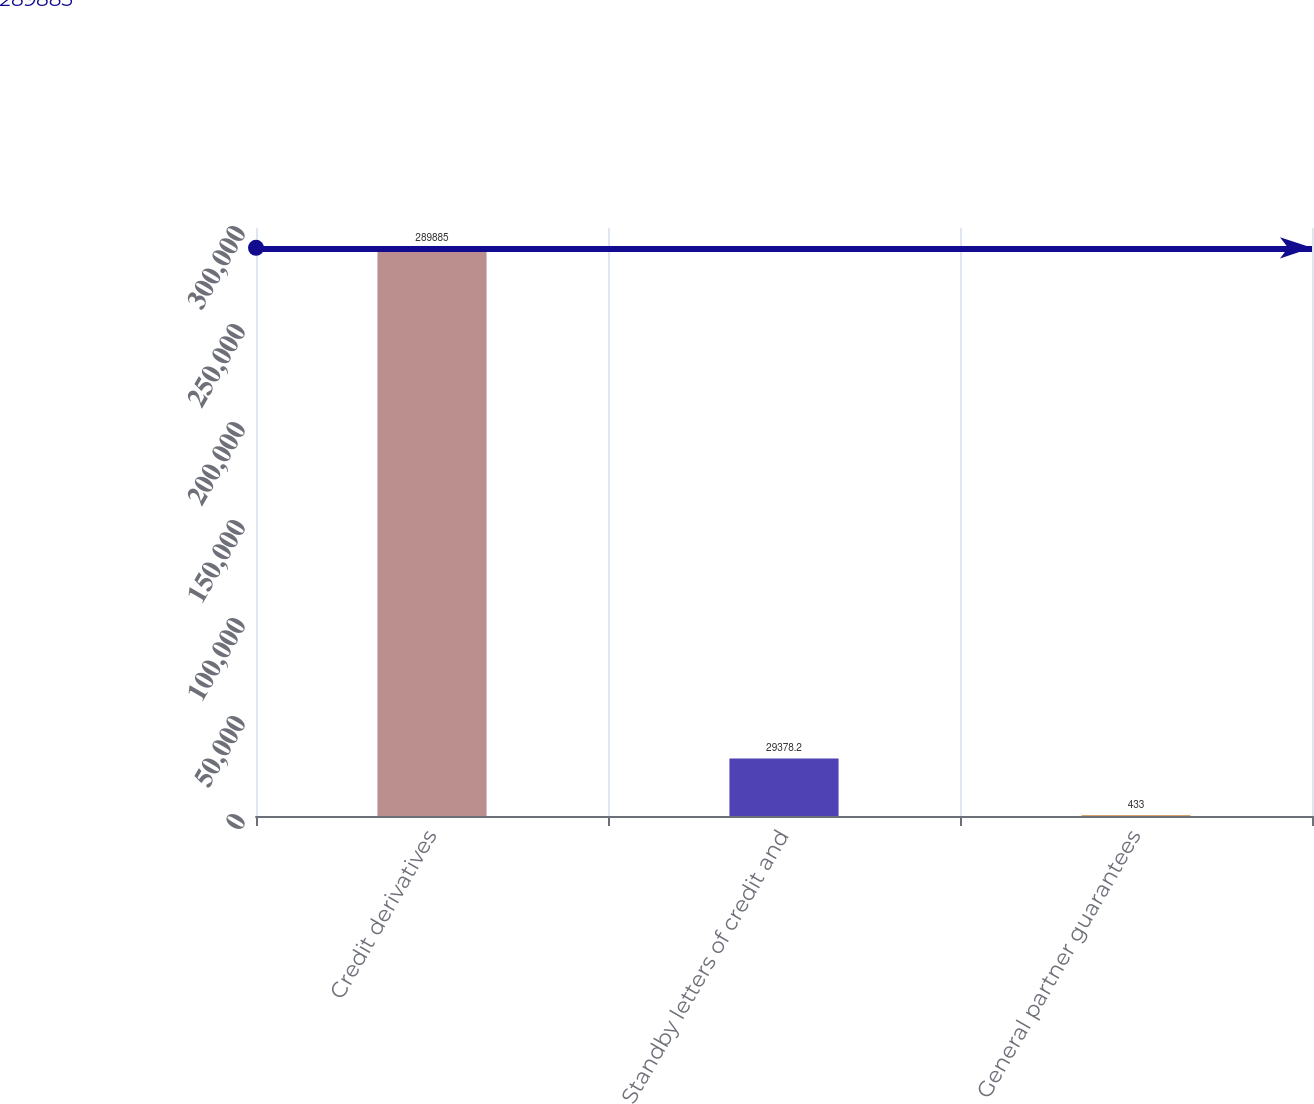<chart> <loc_0><loc_0><loc_500><loc_500><bar_chart><fcel>Credit derivatives<fcel>Standby letters of credit and<fcel>General partner guarantees<nl><fcel>289885<fcel>29378.2<fcel>433<nl></chart> 